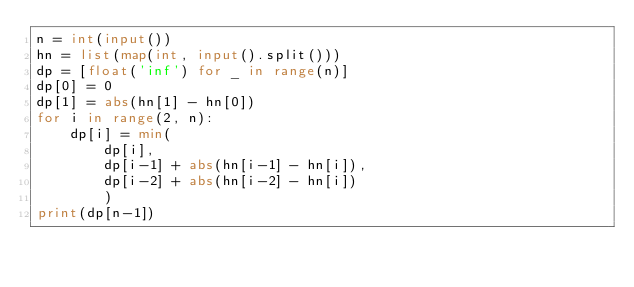Convert code to text. <code><loc_0><loc_0><loc_500><loc_500><_Python_>n = int(input())
hn = list(map(int, input().split()))
dp = [float('inf') for _ in range(n)]
dp[0] = 0
dp[1] = abs(hn[1] - hn[0])
for i in range(2, n):
    dp[i] = min(
        dp[i],
        dp[i-1] + abs(hn[i-1] - hn[i]),
        dp[i-2] + abs(hn[i-2] - hn[i])
        )
print(dp[n-1])
</code> 